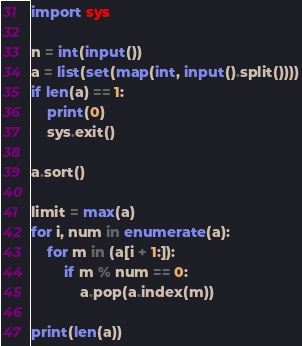<code> <loc_0><loc_0><loc_500><loc_500><_Python_>import sys

n = int(input())
a = list(set(map(int, input().split())))
if len(a) == 1:
    print(0)
    sys.exit()

a.sort()

limit = max(a)
for i, num in enumerate(a):
    for m in (a[i + 1:]):
        if m % num == 0:
            a.pop(a.index(m))

print(len(a))
</code> 